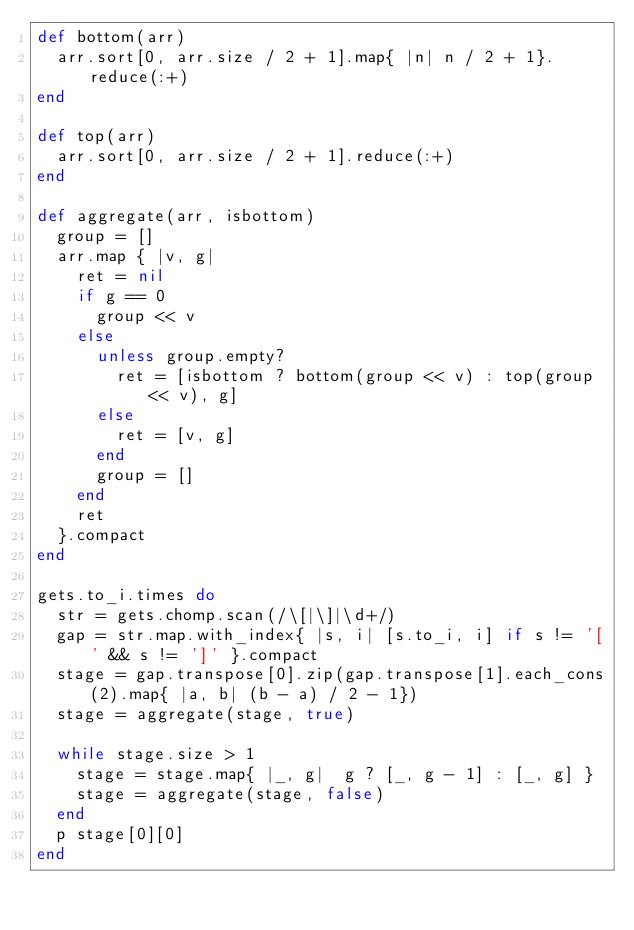Convert code to text. <code><loc_0><loc_0><loc_500><loc_500><_Ruby_>def bottom(arr)
  arr.sort[0, arr.size / 2 + 1].map{ |n| n / 2 + 1}.reduce(:+)
end

def top(arr)
  arr.sort[0, arr.size / 2 + 1].reduce(:+)
end

def aggregate(arr, isbottom)
  group = []
  arr.map { |v, g|
    ret = nil
    if g == 0
      group << v
    else
      unless group.empty?
        ret = [isbottom ? bottom(group << v) : top(group << v), g]
      else
        ret = [v, g]
      end
      group = []
    end
    ret
  }.compact
end

gets.to_i.times do
  str = gets.chomp.scan(/\[|\]|\d+/)
  gap = str.map.with_index{ |s, i| [s.to_i, i] if s != '[' && s != ']' }.compact
  stage = gap.transpose[0].zip(gap.transpose[1].each_cons(2).map{ |a, b| (b - a) / 2 - 1})
  stage = aggregate(stage, true)

  while stage.size > 1
    stage = stage.map{ |_, g|  g ? [_, g - 1] : [_, g] }
    stage = aggregate(stage, false)
  end
  p stage[0][0]
end</code> 